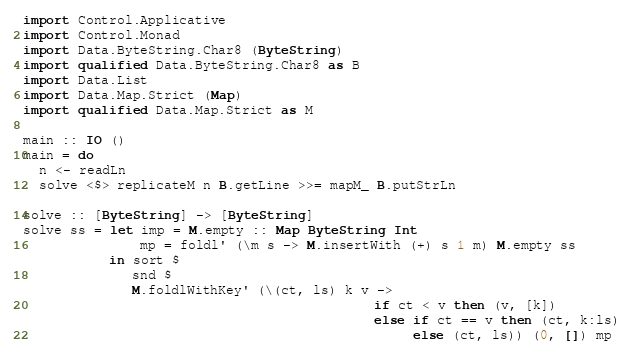Convert code to text. <code><loc_0><loc_0><loc_500><loc_500><_Haskell_>import Control.Applicative
import Control.Monad
import Data.ByteString.Char8 (ByteString)
import qualified Data.ByteString.Char8 as B
import Data.List
import Data.Map.Strict (Map)
import qualified Data.Map.Strict as M

main :: IO ()
main = do
  n <- readLn
  solve <$> replicateM n B.getLine >>= mapM_ B.putStrLn

solve :: [ByteString] -> [ByteString]
solve ss = let imp = M.empty :: Map ByteString Int
               mp = foldl' (\m s -> M.insertWith (+) s 1 m) M.empty ss
           in sort $
              snd $
              M.foldlWithKey' (\(ct, ls) k v ->
                                             if ct < v then (v, [k])
                                             else if ct == v then (ct, k:ls)
                                                  else (ct, ls)) (0, []) mp
</code> 